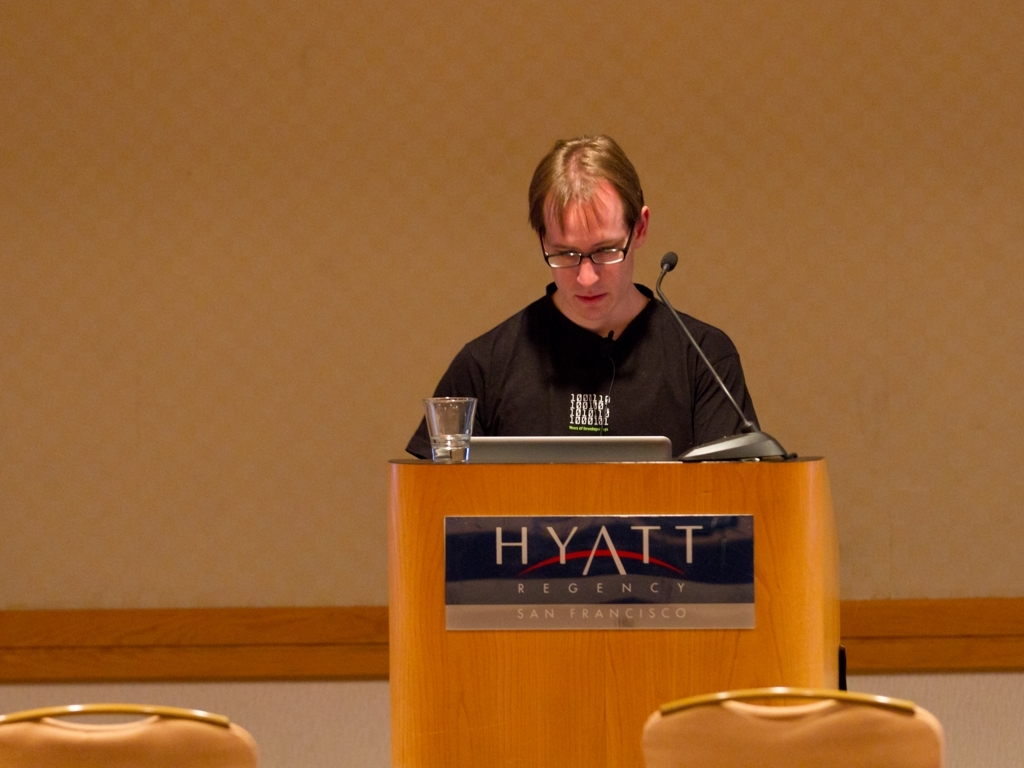What is the subject of this image doing? The individual in the image seems to be giving a presentation or a lecture, as indicated by their position behind a lectern which typically suggests a formal speaking event. 